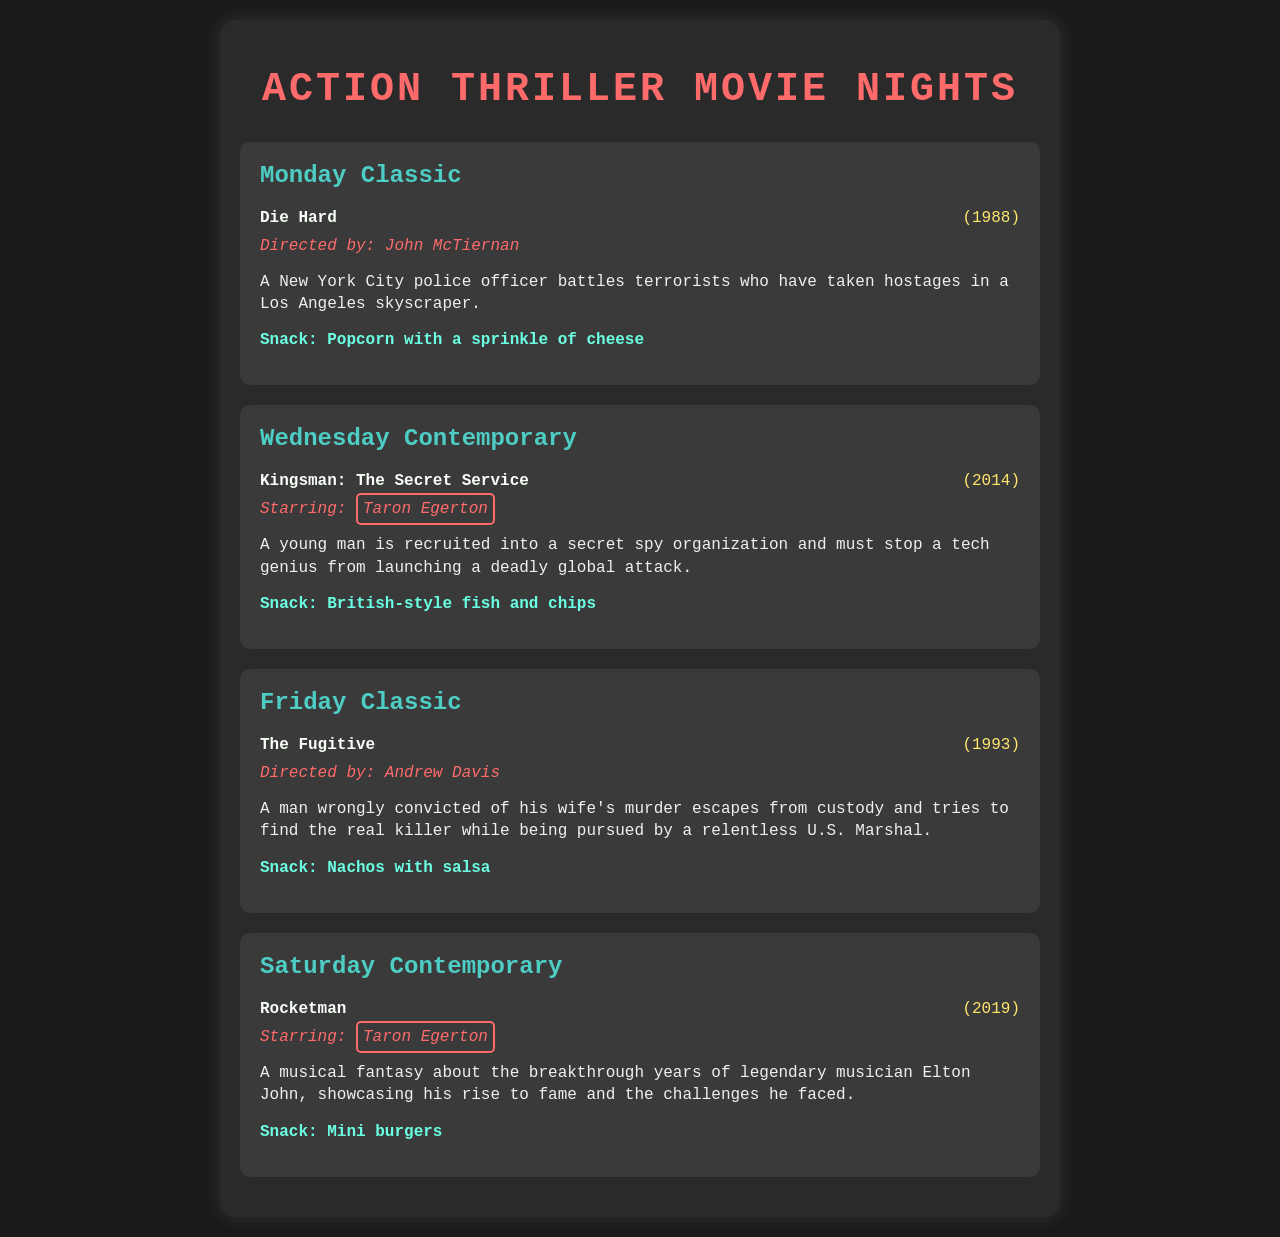What movie is featured on Monday Classic? The document lists "Die Hard" as the movie for Monday Classic, which is specifically mentioned as such.
Answer: Die Hard Who directed The Fugitive? The document states that The Fugitive was directed by Andrew Davis, confirming his directorial role.
Answer: Andrew Davis What is the snack for Wednesday Contemporary? The document mentions "British-style fish and chips" as the snack provided for Wednesday Contemporary.
Answer: British-style fish and chips How many movies star Taron Egerton in this schedule? The document provides information that Taron Egerton stars in two films listed in the schedule.
Answer: Two What year was Kingsman: The Secret Service released? The document specifies that Kingsman: The Secret Service was released in 2014, indicating its release date.
Answer: 2014 What type of snack is paired with The Fugitive? The document describes "Nachos with salsa" as the snack for The Fugitive, highlighting the food pairing for this movie night.
Answer: Nachos with salsa Which film features a tech genius as the antagonist? The document mentions that Kingsman: The Secret Service includes a tech genius attempting a global attack, thereby identifying its antagonist.
Answer: Kingsman: The Secret Service What is the theme of Rocketman? The document describes Rocketman as a "musical fantasy" about Elton John's breakthrough years, capturing its central theme.
Answer: Musical fantasy What day is designated for Friday Classic? The document lists "Friday" specifically as the day for the Classic movie, marking this as its schedule designation.
Answer: Friday 